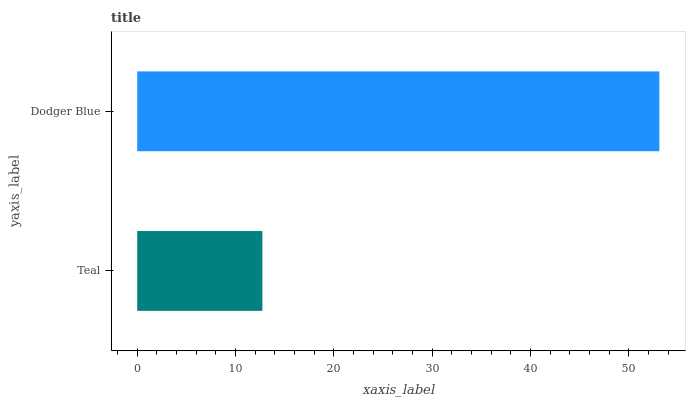Is Teal the minimum?
Answer yes or no. Yes. Is Dodger Blue the maximum?
Answer yes or no. Yes. Is Dodger Blue the minimum?
Answer yes or no. No. Is Dodger Blue greater than Teal?
Answer yes or no. Yes. Is Teal less than Dodger Blue?
Answer yes or no. Yes. Is Teal greater than Dodger Blue?
Answer yes or no. No. Is Dodger Blue less than Teal?
Answer yes or no. No. Is Dodger Blue the high median?
Answer yes or no. Yes. Is Teal the low median?
Answer yes or no. Yes. Is Teal the high median?
Answer yes or no. No. Is Dodger Blue the low median?
Answer yes or no. No. 